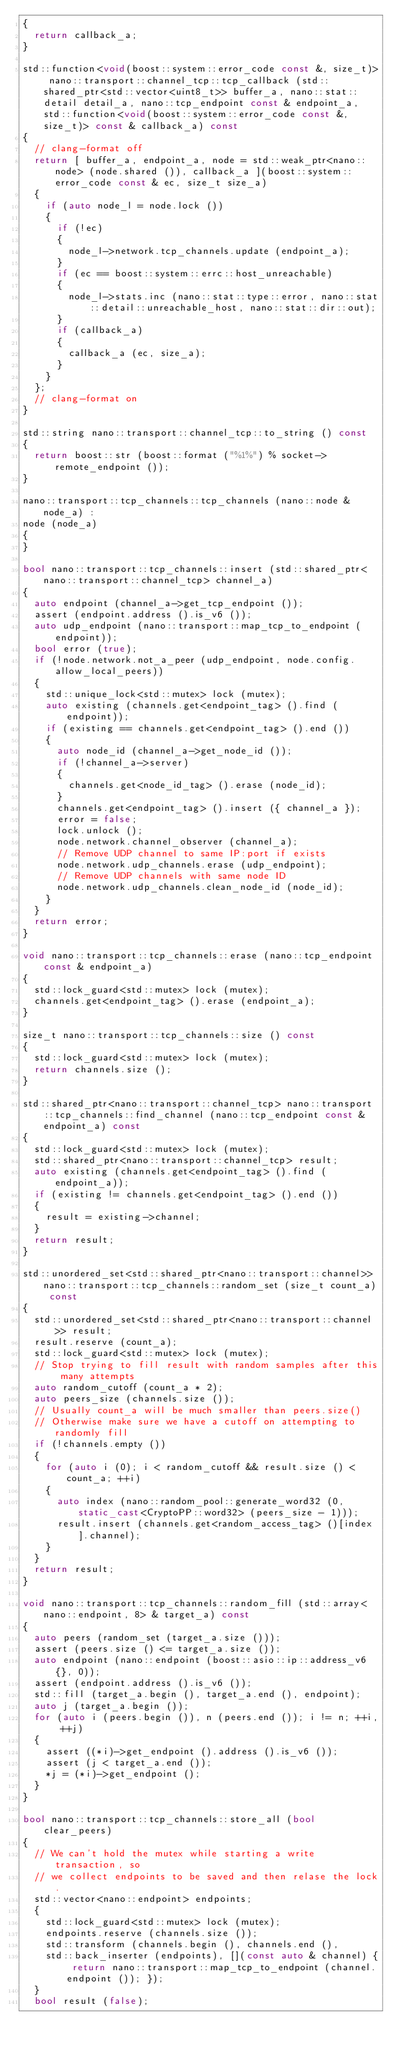Convert code to text. <code><loc_0><loc_0><loc_500><loc_500><_C++_>{
	return callback_a;
}

std::function<void(boost::system::error_code const &, size_t)> nano::transport::channel_tcp::tcp_callback (std::shared_ptr<std::vector<uint8_t>> buffer_a, nano::stat::detail detail_a, nano::tcp_endpoint const & endpoint_a, std::function<void(boost::system::error_code const &, size_t)> const & callback_a) const
{
	// clang-format off
	return [ buffer_a, endpoint_a, node = std::weak_ptr<nano::node> (node.shared ()), callback_a ](boost::system::error_code const & ec, size_t size_a)
	{
		if (auto node_l = node.lock ())
		{
			if (!ec)
			{
				node_l->network.tcp_channels.update (endpoint_a);
			}
			if (ec == boost::system::errc::host_unreachable)
			{
				node_l->stats.inc (nano::stat::type::error, nano::stat::detail::unreachable_host, nano::stat::dir::out);
			}
			if (callback_a)
			{
				callback_a (ec, size_a);
			}
		}
	};
	// clang-format on
}

std::string nano::transport::channel_tcp::to_string () const
{
	return boost::str (boost::format ("%1%") % socket->remote_endpoint ());
}

nano::transport::tcp_channels::tcp_channels (nano::node & node_a) :
node (node_a)
{
}

bool nano::transport::tcp_channels::insert (std::shared_ptr<nano::transport::channel_tcp> channel_a)
{
	auto endpoint (channel_a->get_tcp_endpoint ());
	assert (endpoint.address ().is_v6 ());
	auto udp_endpoint (nano::transport::map_tcp_to_endpoint (endpoint));
	bool error (true);
	if (!node.network.not_a_peer (udp_endpoint, node.config.allow_local_peers))
	{
		std::unique_lock<std::mutex> lock (mutex);
		auto existing (channels.get<endpoint_tag> ().find (endpoint));
		if (existing == channels.get<endpoint_tag> ().end ())
		{
			auto node_id (channel_a->get_node_id ());
			if (!channel_a->server)
			{
				channels.get<node_id_tag> ().erase (node_id);
			}
			channels.get<endpoint_tag> ().insert ({ channel_a });
			error = false;
			lock.unlock ();
			node.network.channel_observer (channel_a);
			// Remove UDP channel to same IP:port if exists
			node.network.udp_channels.erase (udp_endpoint);
			// Remove UDP channels with same node ID
			node.network.udp_channels.clean_node_id (node_id);
		}
	}
	return error;
}

void nano::transport::tcp_channels::erase (nano::tcp_endpoint const & endpoint_a)
{
	std::lock_guard<std::mutex> lock (mutex);
	channels.get<endpoint_tag> ().erase (endpoint_a);
}

size_t nano::transport::tcp_channels::size () const
{
	std::lock_guard<std::mutex> lock (mutex);
	return channels.size ();
}

std::shared_ptr<nano::transport::channel_tcp> nano::transport::tcp_channels::find_channel (nano::tcp_endpoint const & endpoint_a) const
{
	std::lock_guard<std::mutex> lock (mutex);
	std::shared_ptr<nano::transport::channel_tcp> result;
	auto existing (channels.get<endpoint_tag> ().find (endpoint_a));
	if (existing != channels.get<endpoint_tag> ().end ())
	{
		result = existing->channel;
	}
	return result;
}

std::unordered_set<std::shared_ptr<nano::transport::channel>> nano::transport::tcp_channels::random_set (size_t count_a) const
{
	std::unordered_set<std::shared_ptr<nano::transport::channel>> result;
	result.reserve (count_a);
	std::lock_guard<std::mutex> lock (mutex);
	// Stop trying to fill result with random samples after this many attempts
	auto random_cutoff (count_a * 2);
	auto peers_size (channels.size ());
	// Usually count_a will be much smaller than peers.size()
	// Otherwise make sure we have a cutoff on attempting to randomly fill
	if (!channels.empty ())
	{
		for (auto i (0); i < random_cutoff && result.size () < count_a; ++i)
		{
			auto index (nano::random_pool::generate_word32 (0, static_cast<CryptoPP::word32> (peers_size - 1)));
			result.insert (channels.get<random_access_tag> ()[index].channel);
		}
	}
	return result;
}

void nano::transport::tcp_channels::random_fill (std::array<nano::endpoint, 8> & target_a) const
{
	auto peers (random_set (target_a.size ()));
	assert (peers.size () <= target_a.size ());
	auto endpoint (nano::endpoint (boost::asio::ip::address_v6{}, 0));
	assert (endpoint.address ().is_v6 ());
	std::fill (target_a.begin (), target_a.end (), endpoint);
	auto j (target_a.begin ());
	for (auto i (peers.begin ()), n (peers.end ()); i != n; ++i, ++j)
	{
		assert ((*i)->get_endpoint ().address ().is_v6 ());
		assert (j < target_a.end ());
		*j = (*i)->get_endpoint ();
	}
}

bool nano::transport::tcp_channels::store_all (bool clear_peers)
{
	// We can't hold the mutex while starting a write transaction, so
	// we collect endpoints to be saved and then relase the lock.
	std::vector<nano::endpoint> endpoints;
	{
		std::lock_guard<std::mutex> lock (mutex);
		endpoints.reserve (channels.size ());
		std::transform (channels.begin (), channels.end (),
		std::back_inserter (endpoints), [](const auto & channel) { return nano::transport::map_tcp_to_endpoint (channel.endpoint ()); });
	}
	bool result (false);</code> 